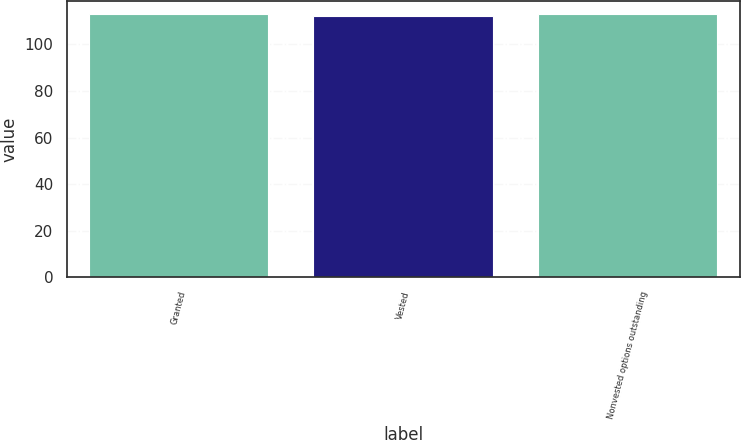Convert chart to OTSL. <chart><loc_0><loc_0><loc_500><loc_500><bar_chart><fcel>Granted<fcel>Vested<fcel>Nonvested options outstanding<nl><fcel>112.98<fcel>112.36<fcel>113.05<nl></chart> 